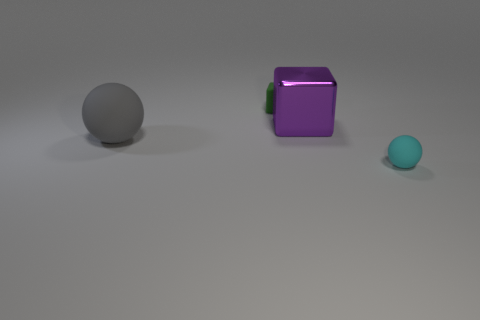Is there any other thing that has the same material as the big cube?
Provide a short and direct response. No. Is there anything else that has the same size as the matte block?
Your response must be concise. Yes. Are there any small matte spheres of the same color as the large matte ball?
Provide a succinct answer. No. Are the small sphere and the large object that is on the right side of the tiny green object made of the same material?
Your response must be concise. No. How many tiny things are matte balls or cubes?
Your response must be concise. 2. Are there fewer green rubber things than large yellow metal cylinders?
Offer a terse response. No. Do the block right of the tiny green thing and the green matte object to the left of the tiny rubber ball have the same size?
Offer a very short reply. No. What number of blue objects are either tiny rubber spheres or rubber spheres?
Give a very brief answer. 0. Are there more matte blocks than small red metal balls?
Ensure brevity in your answer.  Yes. Do the metallic thing and the tiny ball have the same color?
Offer a terse response. No. 